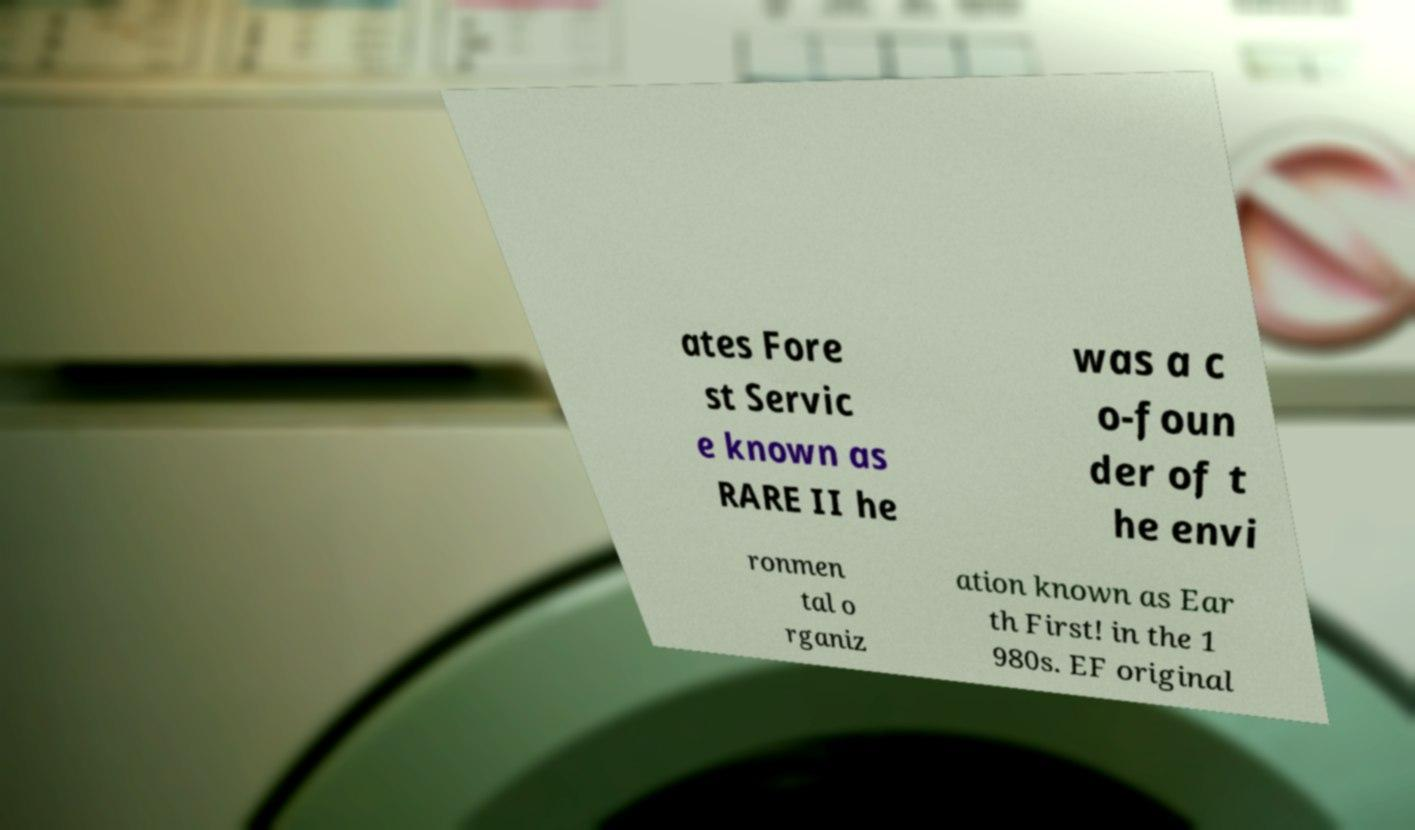I need the written content from this picture converted into text. Can you do that? ates Fore st Servic e known as RARE II he was a c o-foun der of t he envi ronmen tal o rganiz ation known as Ear th First! in the 1 980s. EF original 